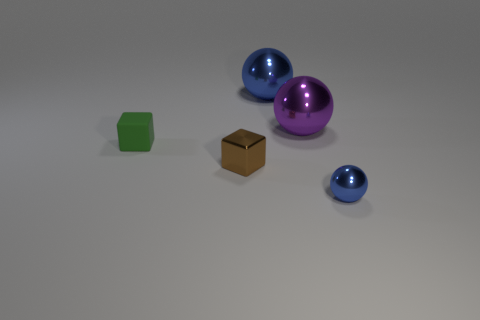Is there any other thing that has the same material as the green cube?
Keep it short and to the point. No. Are there the same number of tiny metal things in front of the brown shiny block and purple objects?
Your answer should be compact. Yes. There is a tiny blue thing; are there any rubber things on the left side of it?
Keep it short and to the point. Yes. What is the size of the blue sphere in front of the small green matte object left of the blue metal sphere that is left of the small ball?
Keep it short and to the point. Small. There is a blue object behind the green matte block; is it the same shape as the large object that is to the right of the large blue shiny object?
Provide a short and direct response. Yes. What is the size of the purple shiny object that is the same shape as the large blue thing?
Provide a succinct answer. Large. What number of tiny brown things are the same material as the large blue sphere?
Your response must be concise. 1. What material is the tiny green block?
Provide a short and direct response. Rubber. The big object on the right side of the blue object behind the matte block is what shape?
Ensure brevity in your answer.  Sphere. There is a metallic object that is on the left side of the big blue shiny thing; what is its shape?
Your answer should be very brief. Cube. 